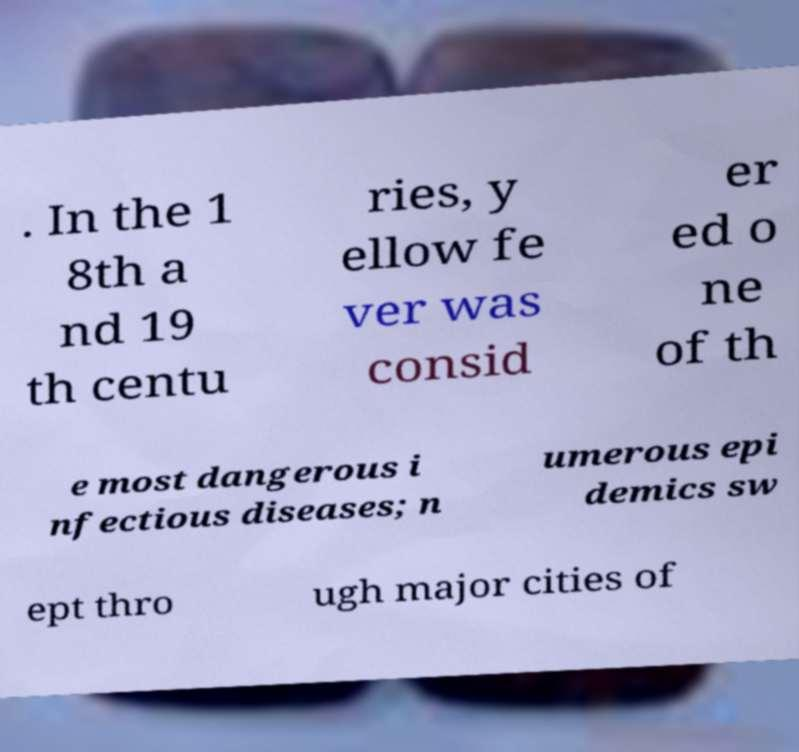Could you extract and type out the text from this image? . In the 1 8th a nd 19 th centu ries, y ellow fe ver was consid er ed o ne of th e most dangerous i nfectious diseases; n umerous epi demics sw ept thro ugh major cities of 